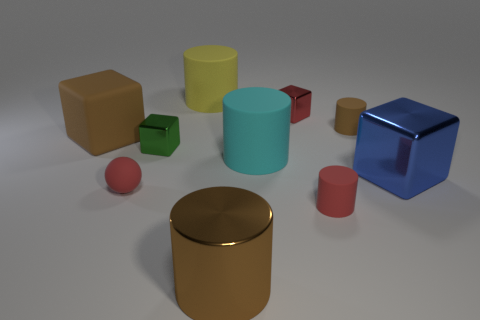Subtract all yellow cylinders. How many cylinders are left? 4 Subtract all tiny brown rubber cylinders. How many cylinders are left? 4 Subtract all gray cylinders. Subtract all green balls. How many cylinders are left? 5 Subtract all spheres. How many objects are left? 9 Subtract all tiny brown rubber things. Subtract all brown rubber things. How many objects are left? 7 Add 7 large blue metallic objects. How many large blue metallic objects are left? 8 Add 8 yellow cylinders. How many yellow cylinders exist? 9 Subtract 1 red balls. How many objects are left? 9 